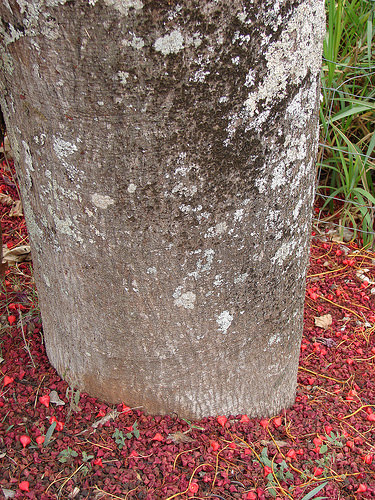<image>
Can you confirm if the plant is above the land? Yes. The plant is positioned above the land in the vertical space, higher up in the scene. 